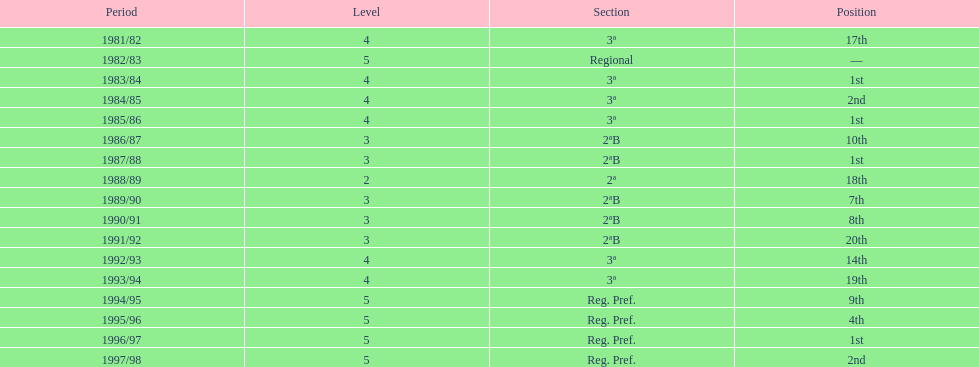What were the number of times second place was earned? 2. 